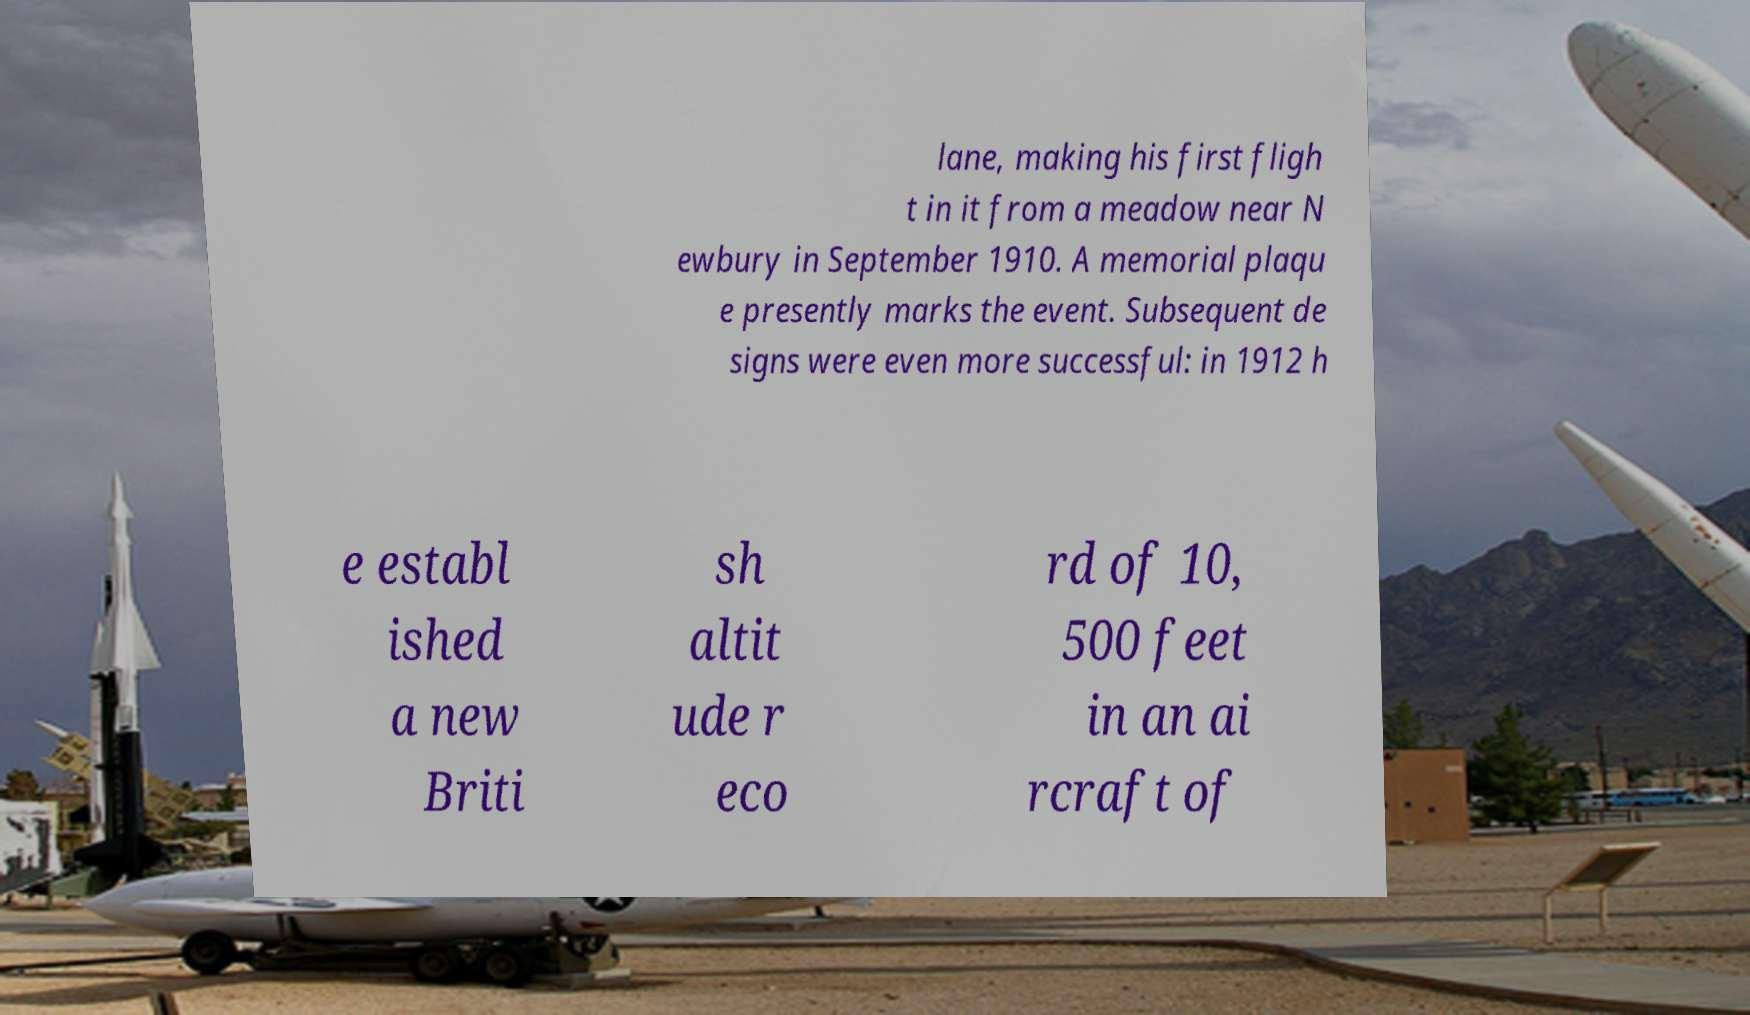For documentation purposes, I need the text within this image transcribed. Could you provide that? lane, making his first fligh t in it from a meadow near N ewbury in September 1910. A memorial plaqu e presently marks the event. Subsequent de signs were even more successful: in 1912 h e establ ished a new Briti sh altit ude r eco rd of 10, 500 feet in an ai rcraft of 